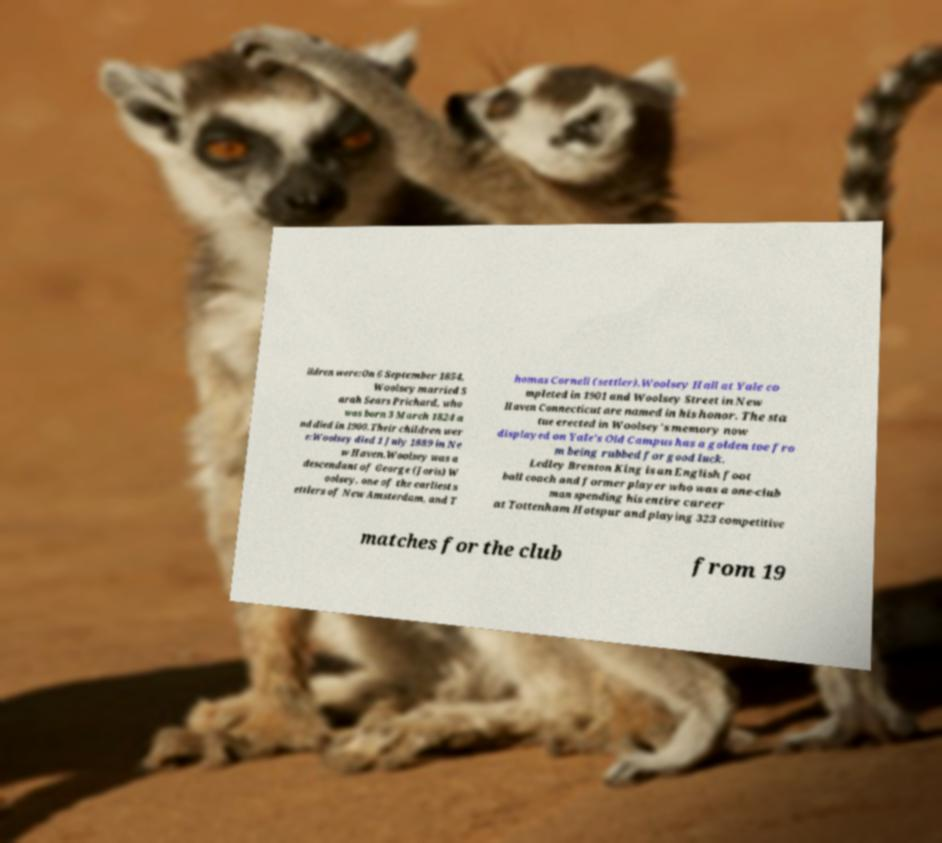Please identify and transcribe the text found in this image. ildren were:On 6 September 1854, Woolsey married S arah Sears Prichard, who was born 3 March 1824 a nd died in 1900.Their children wer e:Woolsey died 1 July 1889 in Ne w Haven.Woolsey was a descendant of George (Joris) W oolsey, one of the earliest s ettlers of New Amsterdam, and T homas Cornell (settler).Woolsey Hall at Yale co mpleted in 1901 and Woolsey Street in New Haven Connecticut are named in his honor. The sta tue erected in Woolsey's memory now displayed on Yale's Old Campus has a golden toe fro m being rubbed for good luck. Ledley Brenton King is an English foot ball coach and former player who was a one-club man spending his entire career at Tottenham Hotspur and playing 323 competitive matches for the club from 19 